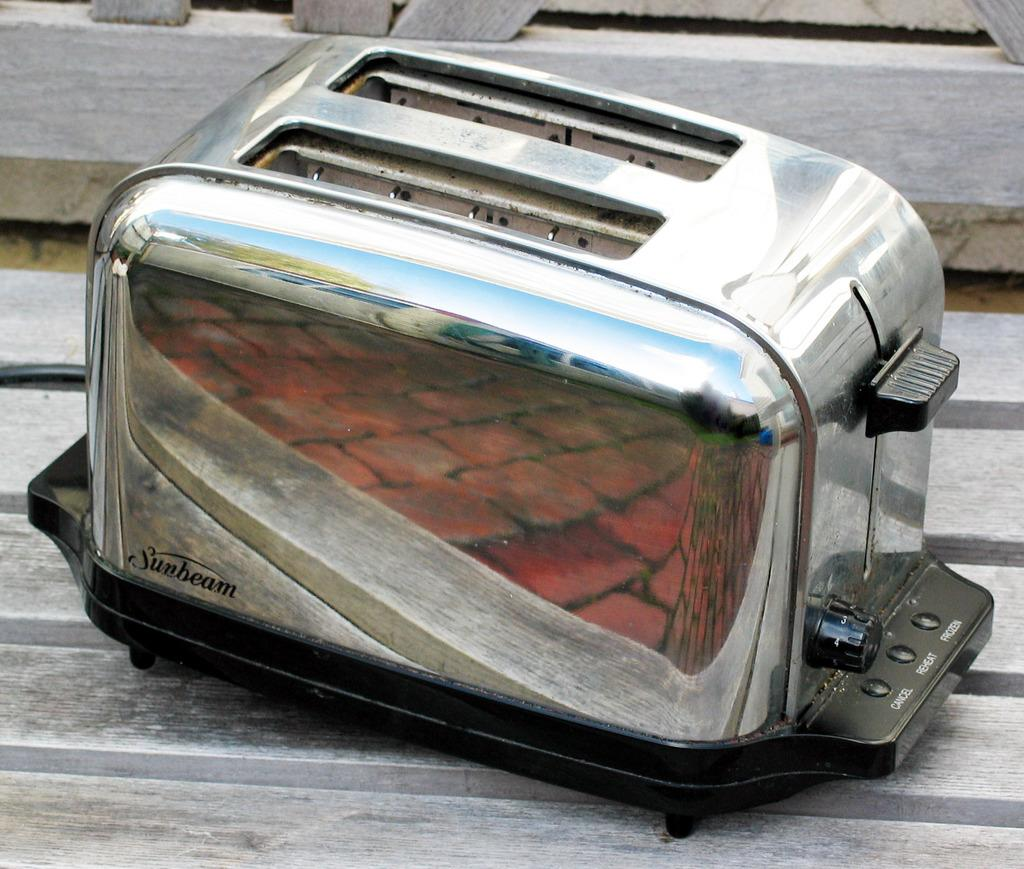What is the color of one of the objects in the image? There is a silver color object in the image. What is the color of the other object in the image? There is a black color object in the image. What type of surface are the objects placed on? Both objects are on a wooden surface. What time does the watch show in the image? There is no watch present in the image, so it is not possible to determine the time. 